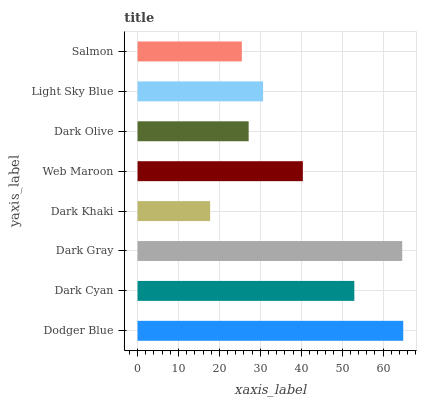Is Dark Khaki the minimum?
Answer yes or no. Yes. Is Dodger Blue the maximum?
Answer yes or no. Yes. Is Dark Cyan the minimum?
Answer yes or no. No. Is Dark Cyan the maximum?
Answer yes or no. No. Is Dodger Blue greater than Dark Cyan?
Answer yes or no. Yes. Is Dark Cyan less than Dodger Blue?
Answer yes or no. Yes. Is Dark Cyan greater than Dodger Blue?
Answer yes or no. No. Is Dodger Blue less than Dark Cyan?
Answer yes or no. No. Is Web Maroon the high median?
Answer yes or no. Yes. Is Light Sky Blue the low median?
Answer yes or no. Yes. Is Dark Khaki the high median?
Answer yes or no. No. Is Dark Khaki the low median?
Answer yes or no. No. 